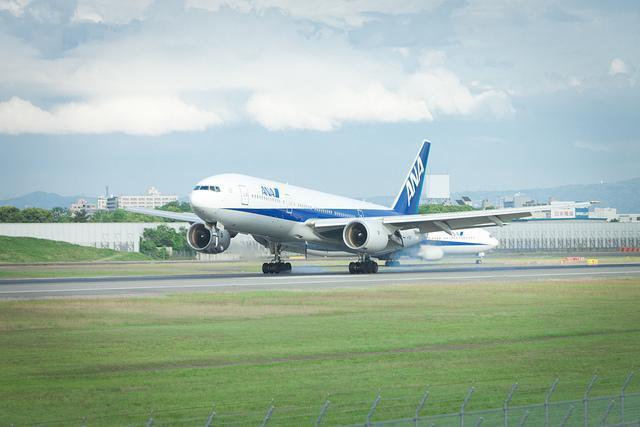How many planes are in this scene?
Give a very brief answer. 2. How many engines do these aircraft have?
Give a very brief answer. 2. How many engines are on the plane?
Give a very brief answer. 2. How many runways are in this photo?
Give a very brief answer. 1. How many airplanes are there?
Give a very brief answer. 2. How many people have on a shirt?
Give a very brief answer. 0. 